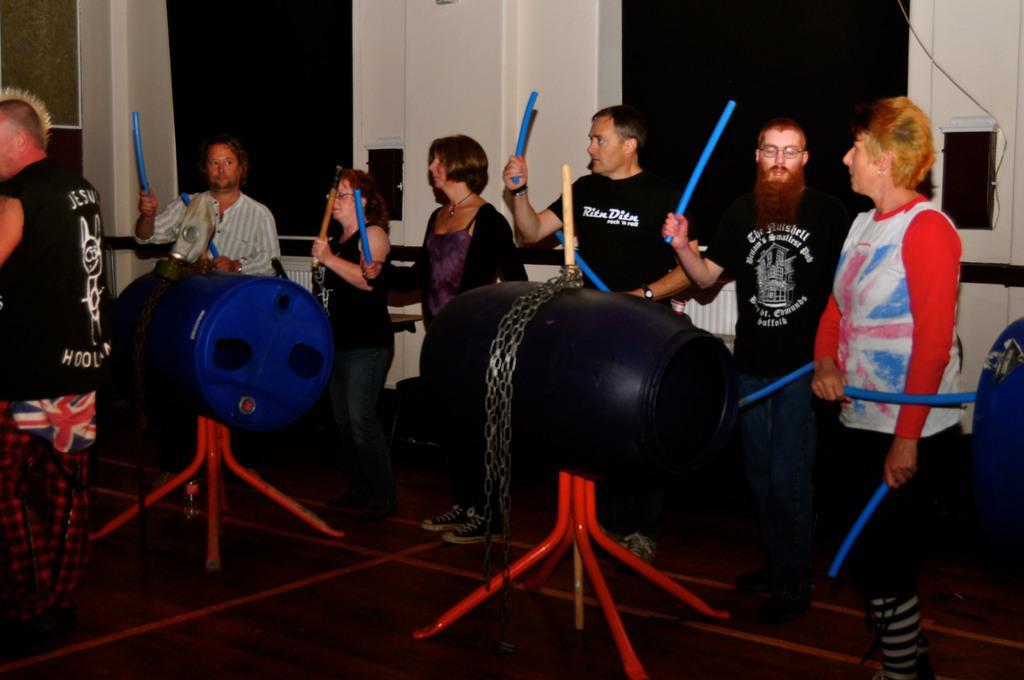How would you summarize this image in a sentence or two? In this image I can see the group of people with different color dresses and these people are holding the sticks. In-front of these people I can see the blue and black color drums on the red color stand. In the background I can see the boards and black color objects to the wall. 